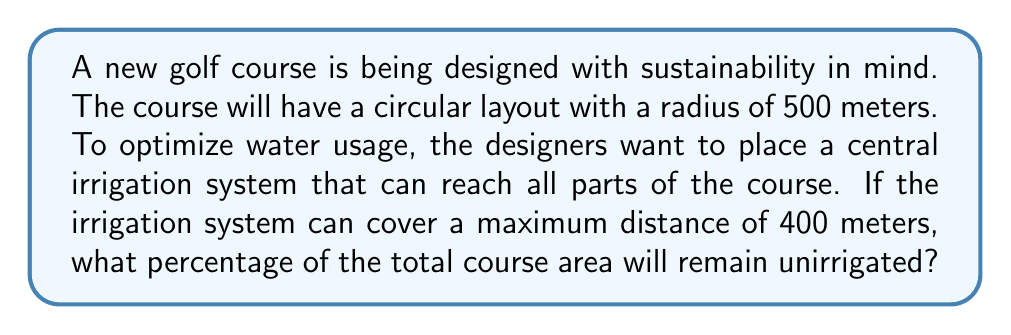Can you solve this math problem? Let's approach this step-by-step:

1) The total area of the circular golf course is:
   $$A_{total} = \pi r^2 = \pi (500)^2 = 250000\pi \text{ m}^2$$

2) The irrigation system can cover a circular area with a radius of 400 meters:
   $$A_{irrigated} = \pi r^2 = \pi (400)^2 = 160000\pi \text{ m}^2$$

3) The unirrigated area is the difference between these:
   $$A_{unirrigated} = A_{total} - A_{irrigated} = 250000\pi - 160000\pi = 90000\pi \text{ m}^2$$

4) To calculate the percentage of unirrigated area:
   $$\text{Percentage} = \frac{A_{unirrigated}}{A_{total}} \times 100\%$$
   
   $$= \frac{90000\pi}{250000\pi} \times 100\% = \frac{90000}{250000} \times 100\% = 0.36 \times 100\% = 36\%$$

[asy]
size(200);
draw(circle((0,0),5), rgb(0,0.7,0));
draw(circle((0,0),4), rgb(0,0,0.7));
label("500m", (2.5,0), E);
label("400m", (2,0), W);
dot((0,0));
[/asy]
Answer: 36% 